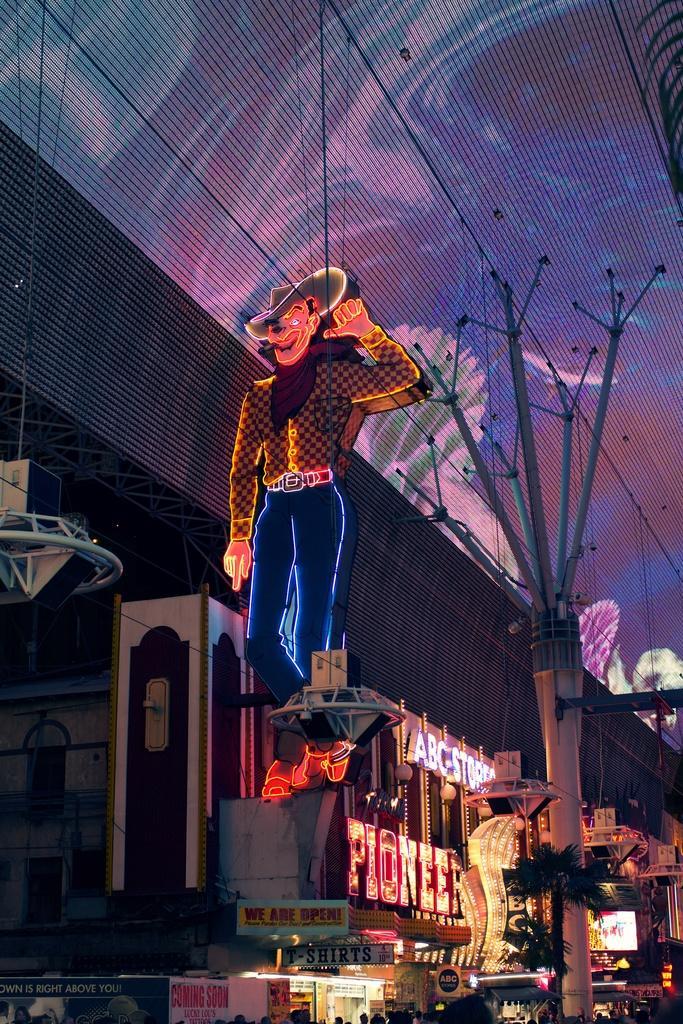Please provide a concise description of this image. In this image there is a building, there are boards, there is text on the boards, there is a pole towards the bottom of the image, there is a tree towards the bottom of the image, there are persons head visible towards the bottom of the image, there is a man, he is wearing a cap, there is roof towards the top of the image, there is an object towards the left of the image, the object is hanging from the roof, there are objects towards the right of the image. 